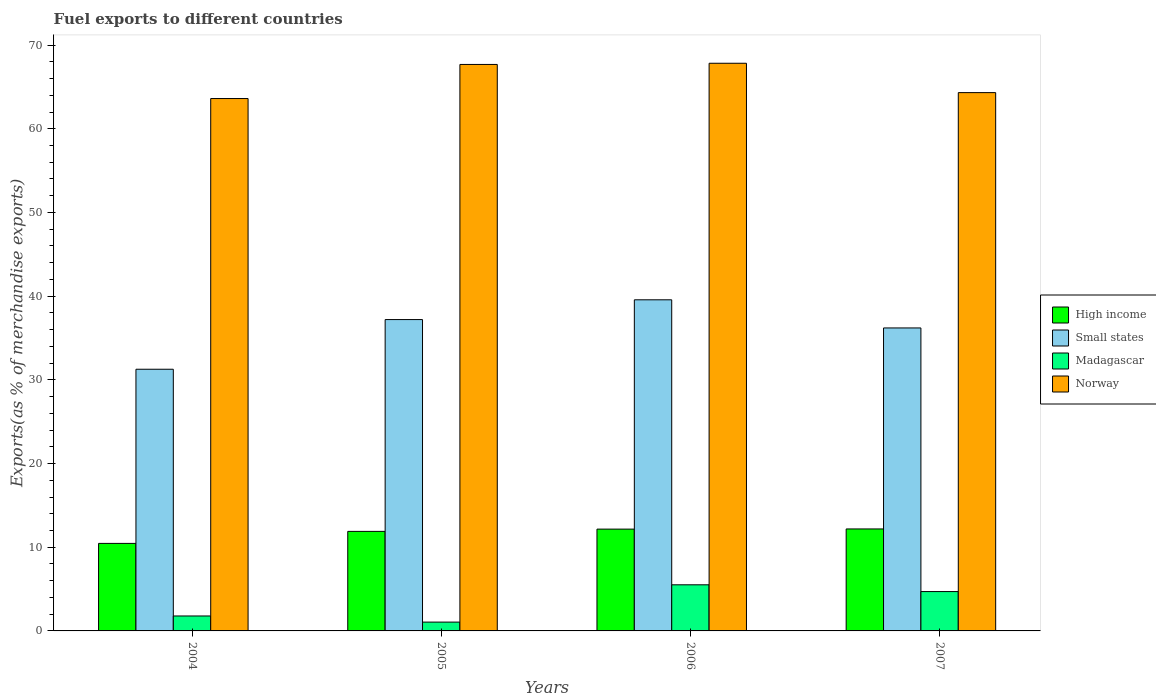How many different coloured bars are there?
Your response must be concise. 4. How many groups of bars are there?
Your answer should be very brief. 4. Are the number of bars per tick equal to the number of legend labels?
Give a very brief answer. Yes. Are the number of bars on each tick of the X-axis equal?
Offer a terse response. Yes. How many bars are there on the 2nd tick from the left?
Offer a terse response. 4. What is the percentage of exports to different countries in Small states in 2004?
Ensure brevity in your answer.  31.27. Across all years, what is the maximum percentage of exports to different countries in Norway?
Your answer should be very brief. 67.83. Across all years, what is the minimum percentage of exports to different countries in High income?
Your answer should be compact. 10.46. In which year was the percentage of exports to different countries in Norway maximum?
Ensure brevity in your answer.  2006. In which year was the percentage of exports to different countries in Small states minimum?
Keep it short and to the point. 2004. What is the total percentage of exports to different countries in Small states in the graph?
Make the answer very short. 144.23. What is the difference between the percentage of exports to different countries in Small states in 2004 and that in 2006?
Ensure brevity in your answer.  -8.3. What is the difference between the percentage of exports to different countries in Small states in 2007 and the percentage of exports to different countries in High income in 2006?
Ensure brevity in your answer.  24.04. What is the average percentage of exports to different countries in Norway per year?
Provide a succinct answer. 65.86. In the year 2007, what is the difference between the percentage of exports to different countries in Madagascar and percentage of exports to different countries in High income?
Your answer should be very brief. -7.48. What is the ratio of the percentage of exports to different countries in Small states in 2006 to that in 2007?
Ensure brevity in your answer.  1.09. Is the percentage of exports to different countries in High income in 2004 less than that in 2005?
Your response must be concise. Yes. Is the difference between the percentage of exports to different countries in Madagascar in 2005 and 2007 greater than the difference between the percentage of exports to different countries in High income in 2005 and 2007?
Give a very brief answer. No. What is the difference between the highest and the second highest percentage of exports to different countries in Madagascar?
Your response must be concise. 0.81. What is the difference between the highest and the lowest percentage of exports to different countries in Madagascar?
Your response must be concise. 4.46. In how many years, is the percentage of exports to different countries in Norway greater than the average percentage of exports to different countries in Norway taken over all years?
Make the answer very short. 2. What does the 1st bar from the left in 2006 represents?
Ensure brevity in your answer.  High income. What does the 2nd bar from the right in 2006 represents?
Make the answer very short. Madagascar. Are all the bars in the graph horizontal?
Provide a short and direct response. No. How many years are there in the graph?
Offer a very short reply. 4. Does the graph contain grids?
Give a very brief answer. No. Where does the legend appear in the graph?
Provide a succinct answer. Center right. How many legend labels are there?
Provide a succinct answer. 4. How are the legend labels stacked?
Make the answer very short. Vertical. What is the title of the graph?
Your answer should be compact. Fuel exports to different countries. Does "Dominican Republic" appear as one of the legend labels in the graph?
Make the answer very short. No. What is the label or title of the X-axis?
Ensure brevity in your answer.  Years. What is the label or title of the Y-axis?
Provide a succinct answer. Exports(as % of merchandise exports). What is the Exports(as % of merchandise exports) in High income in 2004?
Offer a very short reply. 10.46. What is the Exports(as % of merchandise exports) in Small states in 2004?
Make the answer very short. 31.27. What is the Exports(as % of merchandise exports) of Madagascar in 2004?
Keep it short and to the point. 1.79. What is the Exports(as % of merchandise exports) of Norway in 2004?
Ensure brevity in your answer.  63.61. What is the Exports(as % of merchandise exports) of High income in 2005?
Keep it short and to the point. 11.89. What is the Exports(as % of merchandise exports) of Small states in 2005?
Offer a very short reply. 37.2. What is the Exports(as % of merchandise exports) in Madagascar in 2005?
Your response must be concise. 1.05. What is the Exports(as % of merchandise exports) in Norway in 2005?
Provide a short and direct response. 67.69. What is the Exports(as % of merchandise exports) in High income in 2006?
Your answer should be compact. 12.16. What is the Exports(as % of merchandise exports) in Small states in 2006?
Provide a short and direct response. 39.56. What is the Exports(as % of merchandise exports) in Madagascar in 2006?
Make the answer very short. 5.51. What is the Exports(as % of merchandise exports) in Norway in 2006?
Your answer should be compact. 67.83. What is the Exports(as % of merchandise exports) in High income in 2007?
Your answer should be very brief. 12.18. What is the Exports(as % of merchandise exports) in Small states in 2007?
Your answer should be compact. 36.2. What is the Exports(as % of merchandise exports) in Madagascar in 2007?
Give a very brief answer. 4.7. What is the Exports(as % of merchandise exports) in Norway in 2007?
Offer a very short reply. 64.32. Across all years, what is the maximum Exports(as % of merchandise exports) of High income?
Your response must be concise. 12.18. Across all years, what is the maximum Exports(as % of merchandise exports) in Small states?
Make the answer very short. 39.56. Across all years, what is the maximum Exports(as % of merchandise exports) of Madagascar?
Your response must be concise. 5.51. Across all years, what is the maximum Exports(as % of merchandise exports) of Norway?
Your answer should be compact. 67.83. Across all years, what is the minimum Exports(as % of merchandise exports) of High income?
Make the answer very short. 10.46. Across all years, what is the minimum Exports(as % of merchandise exports) of Small states?
Offer a very short reply. 31.27. Across all years, what is the minimum Exports(as % of merchandise exports) of Madagascar?
Give a very brief answer. 1.05. Across all years, what is the minimum Exports(as % of merchandise exports) in Norway?
Keep it short and to the point. 63.61. What is the total Exports(as % of merchandise exports) in High income in the graph?
Ensure brevity in your answer.  46.7. What is the total Exports(as % of merchandise exports) in Small states in the graph?
Offer a terse response. 144.23. What is the total Exports(as % of merchandise exports) of Madagascar in the graph?
Offer a terse response. 13.05. What is the total Exports(as % of merchandise exports) of Norway in the graph?
Give a very brief answer. 263.44. What is the difference between the Exports(as % of merchandise exports) in High income in 2004 and that in 2005?
Offer a very short reply. -1.44. What is the difference between the Exports(as % of merchandise exports) in Small states in 2004 and that in 2005?
Your answer should be compact. -5.93. What is the difference between the Exports(as % of merchandise exports) in Madagascar in 2004 and that in 2005?
Offer a very short reply. 0.73. What is the difference between the Exports(as % of merchandise exports) in Norway in 2004 and that in 2005?
Offer a very short reply. -4.07. What is the difference between the Exports(as % of merchandise exports) in High income in 2004 and that in 2006?
Give a very brief answer. -1.71. What is the difference between the Exports(as % of merchandise exports) of Small states in 2004 and that in 2006?
Ensure brevity in your answer.  -8.3. What is the difference between the Exports(as % of merchandise exports) of Madagascar in 2004 and that in 2006?
Your response must be concise. -3.72. What is the difference between the Exports(as % of merchandise exports) of Norway in 2004 and that in 2006?
Keep it short and to the point. -4.21. What is the difference between the Exports(as % of merchandise exports) in High income in 2004 and that in 2007?
Your response must be concise. -1.73. What is the difference between the Exports(as % of merchandise exports) in Small states in 2004 and that in 2007?
Your response must be concise. -4.93. What is the difference between the Exports(as % of merchandise exports) in Madagascar in 2004 and that in 2007?
Provide a short and direct response. -2.92. What is the difference between the Exports(as % of merchandise exports) in Norway in 2004 and that in 2007?
Give a very brief answer. -0.71. What is the difference between the Exports(as % of merchandise exports) of High income in 2005 and that in 2006?
Provide a succinct answer. -0.27. What is the difference between the Exports(as % of merchandise exports) of Small states in 2005 and that in 2006?
Provide a short and direct response. -2.36. What is the difference between the Exports(as % of merchandise exports) in Madagascar in 2005 and that in 2006?
Make the answer very short. -4.46. What is the difference between the Exports(as % of merchandise exports) in Norway in 2005 and that in 2006?
Your answer should be compact. -0.14. What is the difference between the Exports(as % of merchandise exports) of High income in 2005 and that in 2007?
Your answer should be very brief. -0.29. What is the difference between the Exports(as % of merchandise exports) of Madagascar in 2005 and that in 2007?
Provide a short and direct response. -3.65. What is the difference between the Exports(as % of merchandise exports) of Norway in 2005 and that in 2007?
Your response must be concise. 3.37. What is the difference between the Exports(as % of merchandise exports) in High income in 2006 and that in 2007?
Offer a very short reply. -0.02. What is the difference between the Exports(as % of merchandise exports) of Small states in 2006 and that in 2007?
Your answer should be very brief. 3.36. What is the difference between the Exports(as % of merchandise exports) in Madagascar in 2006 and that in 2007?
Ensure brevity in your answer.  0.81. What is the difference between the Exports(as % of merchandise exports) of Norway in 2006 and that in 2007?
Provide a succinct answer. 3.51. What is the difference between the Exports(as % of merchandise exports) in High income in 2004 and the Exports(as % of merchandise exports) in Small states in 2005?
Your answer should be very brief. -26.74. What is the difference between the Exports(as % of merchandise exports) in High income in 2004 and the Exports(as % of merchandise exports) in Madagascar in 2005?
Give a very brief answer. 9.4. What is the difference between the Exports(as % of merchandise exports) in High income in 2004 and the Exports(as % of merchandise exports) in Norway in 2005?
Offer a terse response. -57.23. What is the difference between the Exports(as % of merchandise exports) of Small states in 2004 and the Exports(as % of merchandise exports) of Madagascar in 2005?
Make the answer very short. 30.21. What is the difference between the Exports(as % of merchandise exports) in Small states in 2004 and the Exports(as % of merchandise exports) in Norway in 2005?
Keep it short and to the point. -36.42. What is the difference between the Exports(as % of merchandise exports) in Madagascar in 2004 and the Exports(as % of merchandise exports) in Norway in 2005?
Give a very brief answer. -65.9. What is the difference between the Exports(as % of merchandise exports) of High income in 2004 and the Exports(as % of merchandise exports) of Small states in 2006?
Ensure brevity in your answer.  -29.11. What is the difference between the Exports(as % of merchandise exports) in High income in 2004 and the Exports(as % of merchandise exports) in Madagascar in 2006?
Offer a terse response. 4.95. What is the difference between the Exports(as % of merchandise exports) of High income in 2004 and the Exports(as % of merchandise exports) of Norway in 2006?
Your answer should be very brief. -57.37. What is the difference between the Exports(as % of merchandise exports) of Small states in 2004 and the Exports(as % of merchandise exports) of Madagascar in 2006?
Give a very brief answer. 25.76. What is the difference between the Exports(as % of merchandise exports) of Small states in 2004 and the Exports(as % of merchandise exports) of Norway in 2006?
Keep it short and to the point. -36.56. What is the difference between the Exports(as % of merchandise exports) in Madagascar in 2004 and the Exports(as % of merchandise exports) in Norway in 2006?
Keep it short and to the point. -66.04. What is the difference between the Exports(as % of merchandise exports) of High income in 2004 and the Exports(as % of merchandise exports) of Small states in 2007?
Give a very brief answer. -25.74. What is the difference between the Exports(as % of merchandise exports) in High income in 2004 and the Exports(as % of merchandise exports) in Madagascar in 2007?
Offer a very short reply. 5.76. What is the difference between the Exports(as % of merchandise exports) of High income in 2004 and the Exports(as % of merchandise exports) of Norway in 2007?
Your answer should be compact. -53.86. What is the difference between the Exports(as % of merchandise exports) of Small states in 2004 and the Exports(as % of merchandise exports) of Madagascar in 2007?
Your answer should be very brief. 26.56. What is the difference between the Exports(as % of merchandise exports) in Small states in 2004 and the Exports(as % of merchandise exports) in Norway in 2007?
Ensure brevity in your answer.  -33.05. What is the difference between the Exports(as % of merchandise exports) of Madagascar in 2004 and the Exports(as % of merchandise exports) of Norway in 2007?
Your response must be concise. -62.53. What is the difference between the Exports(as % of merchandise exports) of High income in 2005 and the Exports(as % of merchandise exports) of Small states in 2006?
Your answer should be very brief. -27.67. What is the difference between the Exports(as % of merchandise exports) in High income in 2005 and the Exports(as % of merchandise exports) in Madagascar in 2006?
Keep it short and to the point. 6.38. What is the difference between the Exports(as % of merchandise exports) in High income in 2005 and the Exports(as % of merchandise exports) in Norway in 2006?
Your response must be concise. -55.93. What is the difference between the Exports(as % of merchandise exports) in Small states in 2005 and the Exports(as % of merchandise exports) in Madagascar in 2006?
Keep it short and to the point. 31.69. What is the difference between the Exports(as % of merchandise exports) in Small states in 2005 and the Exports(as % of merchandise exports) in Norway in 2006?
Provide a succinct answer. -30.63. What is the difference between the Exports(as % of merchandise exports) in Madagascar in 2005 and the Exports(as % of merchandise exports) in Norway in 2006?
Your answer should be compact. -66.77. What is the difference between the Exports(as % of merchandise exports) of High income in 2005 and the Exports(as % of merchandise exports) of Small states in 2007?
Ensure brevity in your answer.  -24.31. What is the difference between the Exports(as % of merchandise exports) in High income in 2005 and the Exports(as % of merchandise exports) in Madagascar in 2007?
Provide a succinct answer. 7.19. What is the difference between the Exports(as % of merchandise exports) of High income in 2005 and the Exports(as % of merchandise exports) of Norway in 2007?
Your response must be concise. -52.43. What is the difference between the Exports(as % of merchandise exports) of Small states in 2005 and the Exports(as % of merchandise exports) of Madagascar in 2007?
Your response must be concise. 32.5. What is the difference between the Exports(as % of merchandise exports) of Small states in 2005 and the Exports(as % of merchandise exports) of Norway in 2007?
Ensure brevity in your answer.  -27.12. What is the difference between the Exports(as % of merchandise exports) of Madagascar in 2005 and the Exports(as % of merchandise exports) of Norway in 2007?
Give a very brief answer. -63.27. What is the difference between the Exports(as % of merchandise exports) in High income in 2006 and the Exports(as % of merchandise exports) in Small states in 2007?
Offer a terse response. -24.04. What is the difference between the Exports(as % of merchandise exports) in High income in 2006 and the Exports(as % of merchandise exports) in Madagascar in 2007?
Give a very brief answer. 7.46. What is the difference between the Exports(as % of merchandise exports) in High income in 2006 and the Exports(as % of merchandise exports) in Norway in 2007?
Your answer should be compact. -52.16. What is the difference between the Exports(as % of merchandise exports) in Small states in 2006 and the Exports(as % of merchandise exports) in Madagascar in 2007?
Your answer should be compact. 34.86. What is the difference between the Exports(as % of merchandise exports) in Small states in 2006 and the Exports(as % of merchandise exports) in Norway in 2007?
Keep it short and to the point. -24.76. What is the difference between the Exports(as % of merchandise exports) of Madagascar in 2006 and the Exports(as % of merchandise exports) of Norway in 2007?
Your answer should be compact. -58.81. What is the average Exports(as % of merchandise exports) of High income per year?
Your answer should be compact. 11.68. What is the average Exports(as % of merchandise exports) in Small states per year?
Your answer should be very brief. 36.06. What is the average Exports(as % of merchandise exports) of Madagascar per year?
Your response must be concise. 3.26. What is the average Exports(as % of merchandise exports) of Norway per year?
Your answer should be very brief. 65.86. In the year 2004, what is the difference between the Exports(as % of merchandise exports) of High income and Exports(as % of merchandise exports) of Small states?
Your answer should be compact. -20.81. In the year 2004, what is the difference between the Exports(as % of merchandise exports) in High income and Exports(as % of merchandise exports) in Madagascar?
Provide a succinct answer. 8.67. In the year 2004, what is the difference between the Exports(as % of merchandise exports) of High income and Exports(as % of merchandise exports) of Norway?
Provide a succinct answer. -53.15. In the year 2004, what is the difference between the Exports(as % of merchandise exports) in Small states and Exports(as % of merchandise exports) in Madagascar?
Make the answer very short. 29.48. In the year 2004, what is the difference between the Exports(as % of merchandise exports) in Small states and Exports(as % of merchandise exports) in Norway?
Your answer should be compact. -32.35. In the year 2004, what is the difference between the Exports(as % of merchandise exports) of Madagascar and Exports(as % of merchandise exports) of Norway?
Your response must be concise. -61.83. In the year 2005, what is the difference between the Exports(as % of merchandise exports) in High income and Exports(as % of merchandise exports) in Small states?
Ensure brevity in your answer.  -25.31. In the year 2005, what is the difference between the Exports(as % of merchandise exports) in High income and Exports(as % of merchandise exports) in Madagascar?
Give a very brief answer. 10.84. In the year 2005, what is the difference between the Exports(as % of merchandise exports) in High income and Exports(as % of merchandise exports) in Norway?
Provide a short and direct response. -55.79. In the year 2005, what is the difference between the Exports(as % of merchandise exports) of Small states and Exports(as % of merchandise exports) of Madagascar?
Offer a very short reply. 36.15. In the year 2005, what is the difference between the Exports(as % of merchandise exports) in Small states and Exports(as % of merchandise exports) in Norway?
Keep it short and to the point. -30.48. In the year 2005, what is the difference between the Exports(as % of merchandise exports) in Madagascar and Exports(as % of merchandise exports) in Norway?
Offer a terse response. -66.63. In the year 2006, what is the difference between the Exports(as % of merchandise exports) in High income and Exports(as % of merchandise exports) in Small states?
Provide a short and direct response. -27.4. In the year 2006, what is the difference between the Exports(as % of merchandise exports) of High income and Exports(as % of merchandise exports) of Madagascar?
Your answer should be compact. 6.65. In the year 2006, what is the difference between the Exports(as % of merchandise exports) in High income and Exports(as % of merchandise exports) in Norway?
Offer a terse response. -55.66. In the year 2006, what is the difference between the Exports(as % of merchandise exports) in Small states and Exports(as % of merchandise exports) in Madagascar?
Make the answer very short. 34.05. In the year 2006, what is the difference between the Exports(as % of merchandise exports) in Small states and Exports(as % of merchandise exports) in Norway?
Your answer should be compact. -28.26. In the year 2006, what is the difference between the Exports(as % of merchandise exports) in Madagascar and Exports(as % of merchandise exports) in Norway?
Provide a short and direct response. -62.32. In the year 2007, what is the difference between the Exports(as % of merchandise exports) in High income and Exports(as % of merchandise exports) in Small states?
Keep it short and to the point. -24.02. In the year 2007, what is the difference between the Exports(as % of merchandise exports) of High income and Exports(as % of merchandise exports) of Madagascar?
Provide a succinct answer. 7.48. In the year 2007, what is the difference between the Exports(as % of merchandise exports) of High income and Exports(as % of merchandise exports) of Norway?
Make the answer very short. -52.13. In the year 2007, what is the difference between the Exports(as % of merchandise exports) in Small states and Exports(as % of merchandise exports) in Madagascar?
Keep it short and to the point. 31.5. In the year 2007, what is the difference between the Exports(as % of merchandise exports) in Small states and Exports(as % of merchandise exports) in Norway?
Provide a short and direct response. -28.12. In the year 2007, what is the difference between the Exports(as % of merchandise exports) in Madagascar and Exports(as % of merchandise exports) in Norway?
Make the answer very short. -59.62. What is the ratio of the Exports(as % of merchandise exports) in High income in 2004 to that in 2005?
Provide a short and direct response. 0.88. What is the ratio of the Exports(as % of merchandise exports) in Small states in 2004 to that in 2005?
Keep it short and to the point. 0.84. What is the ratio of the Exports(as % of merchandise exports) of Madagascar in 2004 to that in 2005?
Provide a succinct answer. 1.69. What is the ratio of the Exports(as % of merchandise exports) in Norway in 2004 to that in 2005?
Keep it short and to the point. 0.94. What is the ratio of the Exports(as % of merchandise exports) of High income in 2004 to that in 2006?
Offer a very short reply. 0.86. What is the ratio of the Exports(as % of merchandise exports) in Small states in 2004 to that in 2006?
Provide a short and direct response. 0.79. What is the ratio of the Exports(as % of merchandise exports) in Madagascar in 2004 to that in 2006?
Your answer should be very brief. 0.32. What is the ratio of the Exports(as % of merchandise exports) in Norway in 2004 to that in 2006?
Your response must be concise. 0.94. What is the ratio of the Exports(as % of merchandise exports) in High income in 2004 to that in 2007?
Make the answer very short. 0.86. What is the ratio of the Exports(as % of merchandise exports) of Small states in 2004 to that in 2007?
Your answer should be very brief. 0.86. What is the ratio of the Exports(as % of merchandise exports) of Madagascar in 2004 to that in 2007?
Ensure brevity in your answer.  0.38. What is the ratio of the Exports(as % of merchandise exports) in Norway in 2004 to that in 2007?
Make the answer very short. 0.99. What is the ratio of the Exports(as % of merchandise exports) in High income in 2005 to that in 2006?
Your answer should be compact. 0.98. What is the ratio of the Exports(as % of merchandise exports) of Small states in 2005 to that in 2006?
Offer a terse response. 0.94. What is the ratio of the Exports(as % of merchandise exports) in Madagascar in 2005 to that in 2006?
Offer a very short reply. 0.19. What is the ratio of the Exports(as % of merchandise exports) of High income in 2005 to that in 2007?
Your answer should be very brief. 0.98. What is the ratio of the Exports(as % of merchandise exports) in Small states in 2005 to that in 2007?
Your answer should be very brief. 1.03. What is the ratio of the Exports(as % of merchandise exports) in Madagascar in 2005 to that in 2007?
Ensure brevity in your answer.  0.22. What is the ratio of the Exports(as % of merchandise exports) in Norway in 2005 to that in 2007?
Your answer should be compact. 1.05. What is the ratio of the Exports(as % of merchandise exports) in Small states in 2006 to that in 2007?
Make the answer very short. 1.09. What is the ratio of the Exports(as % of merchandise exports) of Madagascar in 2006 to that in 2007?
Give a very brief answer. 1.17. What is the ratio of the Exports(as % of merchandise exports) in Norway in 2006 to that in 2007?
Ensure brevity in your answer.  1.05. What is the difference between the highest and the second highest Exports(as % of merchandise exports) of High income?
Provide a short and direct response. 0.02. What is the difference between the highest and the second highest Exports(as % of merchandise exports) in Small states?
Offer a terse response. 2.36. What is the difference between the highest and the second highest Exports(as % of merchandise exports) in Madagascar?
Your answer should be compact. 0.81. What is the difference between the highest and the second highest Exports(as % of merchandise exports) in Norway?
Ensure brevity in your answer.  0.14. What is the difference between the highest and the lowest Exports(as % of merchandise exports) of High income?
Your answer should be compact. 1.73. What is the difference between the highest and the lowest Exports(as % of merchandise exports) of Small states?
Keep it short and to the point. 8.3. What is the difference between the highest and the lowest Exports(as % of merchandise exports) of Madagascar?
Make the answer very short. 4.46. What is the difference between the highest and the lowest Exports(as % of merchandise exports) in Norway?
Your answer should be very brief. 4.21. 